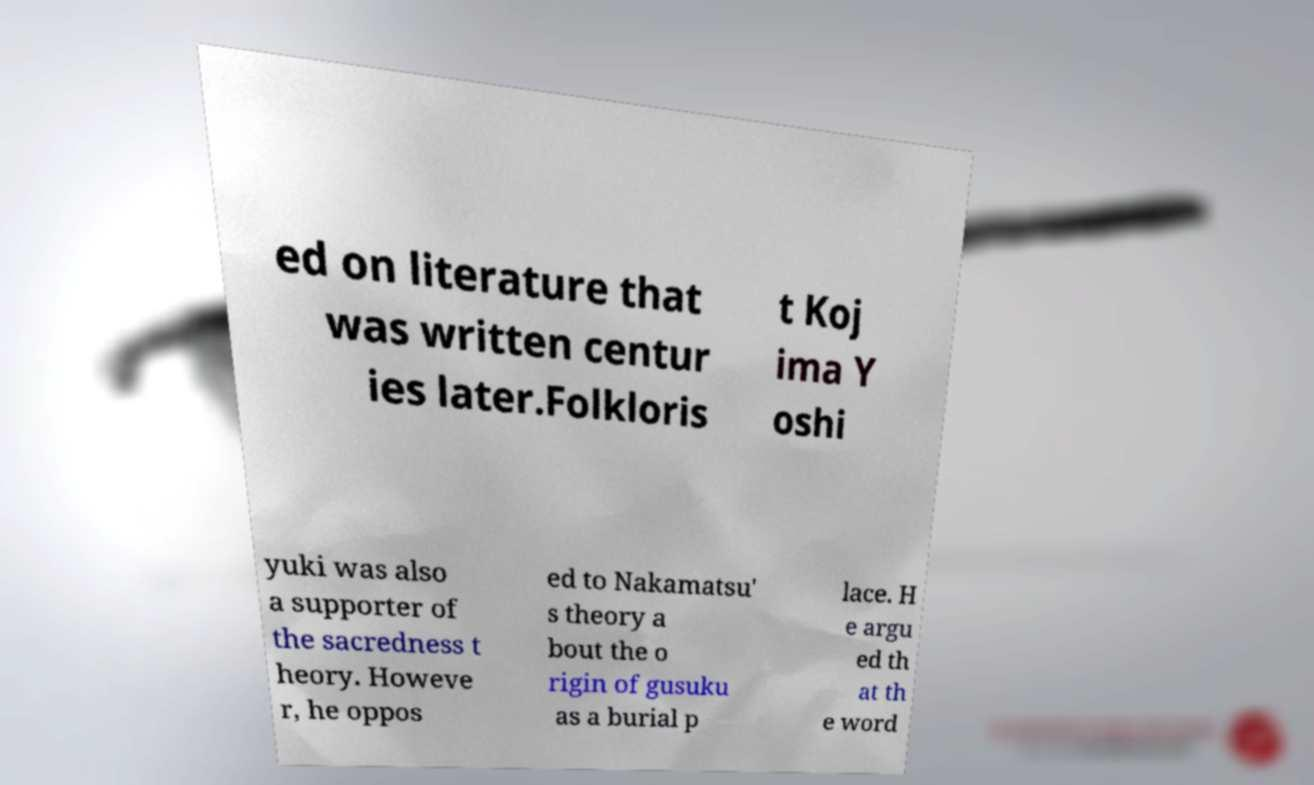Please identify and transcribe the text found in this image. ed on literature that was written centur ies later.Folkloris t Koj ima Y oshi yuki was also a supporter of the sacredness t heory. Howeve r, he oppos ed to Nakamatsu' s theory a bout the o rigin of gusuku as a burial p lace. H e argu ed th at th e word 